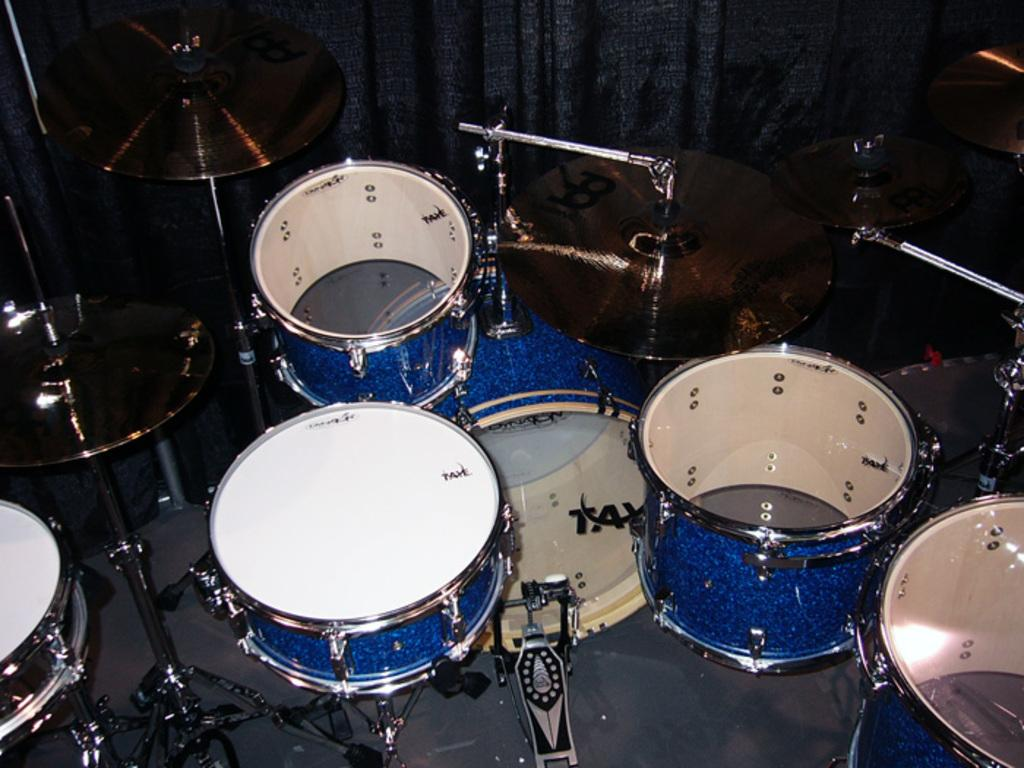What object in the image is used for creating music? There is a musical instrument in the image. What can be seen in the background of the image? There is a curtain in the background of the image. What type of lock is used to secure the store in the image? There is no store or lock present in the image; it only features a musical instrument and a curtain in the background. 